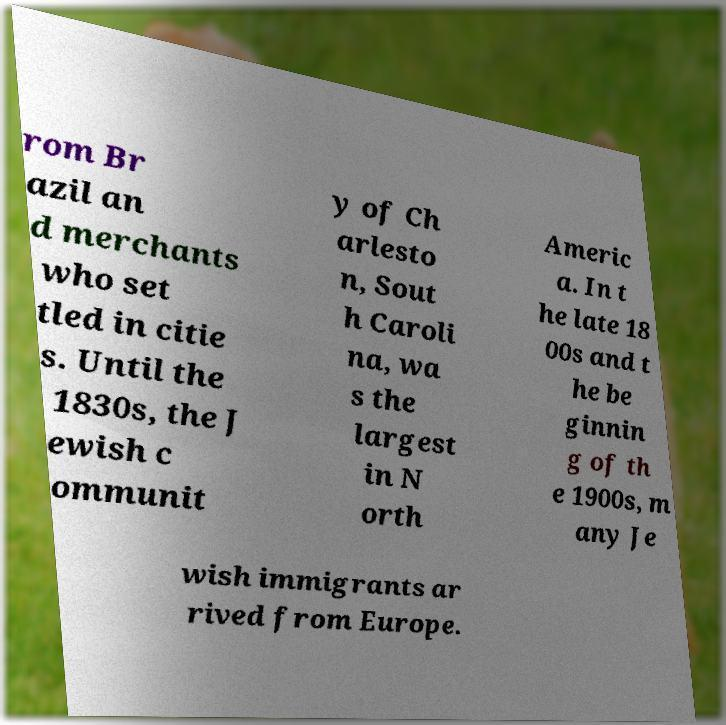For documentation purposes, I need the text within this image transcribed. Could you provide that? rom Br azil an d merchants who set tled in citie s. Until the 1830s, the J ewish c ommunit y of Ch arlesto n, Sout h Caroli na, wa s the largest in N orth Americ a. In t he late 18 00s and t he be ginnin g of th e 1900s, m any Je wish immigrants ar rived from Europe. 